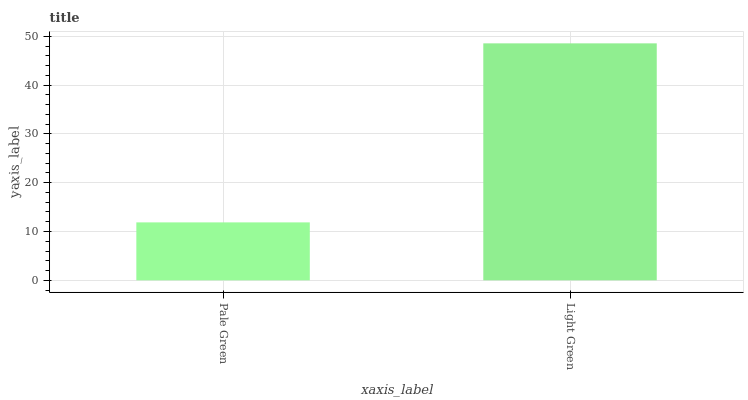Is Pale Green the minimum?
Answer yes or no. Yes. Is Light Green the maximum?
Answer yes or no. Yes. Is Light Green the minimum?
Answer yes or no. No. Is Light Green greater than Pale Green?
Answer yes or no. Yes. Is Pale Green less than Light Green?
Answer yes or no. Yes. Is Pale Green greater than Light Green?
Answer yes or no. No. Is Light Green less than Pale Green?
Answer yes or no. No. Is Light Green the high median?
Answer yes or no. Yes. Is Pale Green the low median?
Answer yes or no. Yes. Is Pale Green the high median?
Answer yes or no. No. Is Light Green the low median?
Answer yes or no. No. 